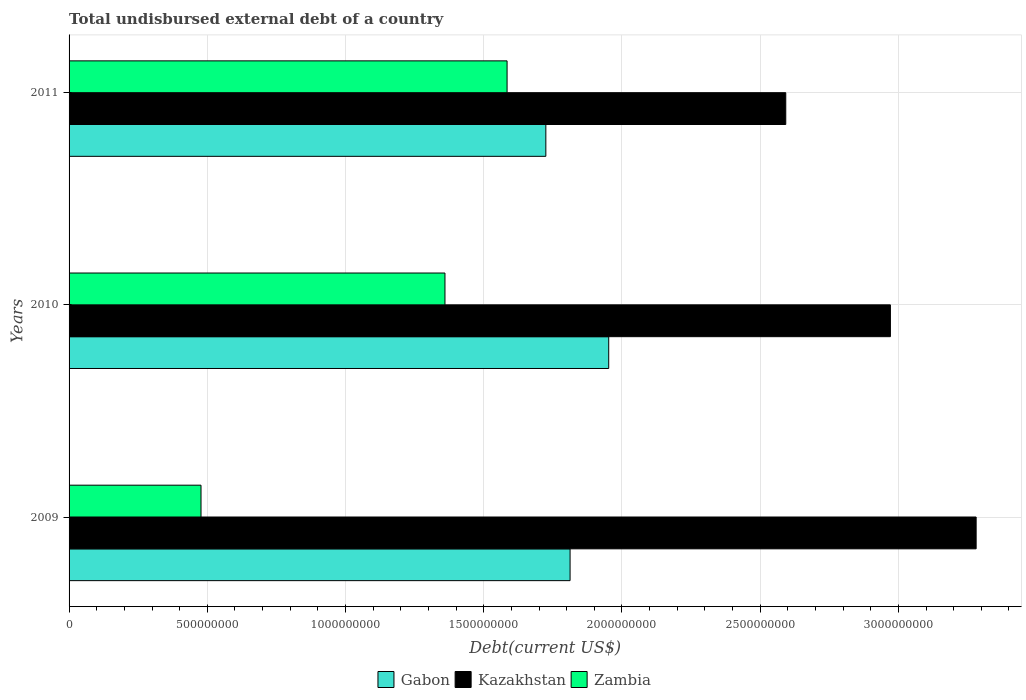How many groups of bars are there?
Give a very brief answer. 3. Are the number of bars per tick equal to the number of legend labels?
Your answer should be very brief. Yes. How many bars are there on the 1st tick from the top?
Provide a succinct answer. 3. What is the total undisbursed external debt in Kazakhstan in 2009?
Provide a succinct answer. 3.28e+09. Across all years, what is the maximum total undisbursed external debt in Zambia?
Provide a succinct answer. 1.58e+09. Across all years, what is the minimum total undisbursed external debt in Zambia?
Provide a succinct answer. 4.77e+08. In which year was the total undisbursed external debt in Kazakhstan maximum?
Give a very brief answer. 2009. In which year was the total undisbursed external debt in Gabon minimum?
Give a very brief answer. 2011. What is the total total undisbursed external debt in Zambia in the graph?
Offer a terse response. 3.42e+09. What is the difference between the total undisbursed external debt in Kazakhstan in 2009 and that in 2010?
Provide a succinct answer. 3.10e+08. What is the difference between the total undisbursed external debt in Gabon in 2010 and the total undisbursed external debt in Kazakhstan in 2011?
Your answer should be very brief. -6.40e+08. What is the average total undisbursed external debt in Kazakhstan per year?
Give a very brief answer. 2.95e+09. In the year 2011, what is the difference between the total undisbursed external debt in Gabon and total undisbursed external debt in Kazakhstan?
Offer a terse response. -8.68e+08. In how many years, is the total undisbursed external debt in Zambia greater than 2500000000 US$?
Your answer should be compact. 0. What is the ratio of the total undisbursed external debt in Zambia in 2010 to that in 2011?
Your answer should be very brief. 0.86. Is the total undisbursed external debt in Zambia in 2009 less than that in 2010?
Make the answer very short. Yes. Is the difference between the total undisbursed external debt in Gabon in 2009 and 2010 greater than the difference between the total undisbursed external debt in Kazakhstan in 2009 and 2010?
Give a very brief answer. No. What is the difference between the highest and the second highest total undisbursed external debt in Gabon?
Give a very brief answer. 1.40e+08. What is the difference between the highest and the lowest total undisbursed external debt in Kazakhstan?
Offer a terse response. 6.89e+08. In how many years, is the total undisbursed external debt in Kazakhstan greater than the average total undisbursed external debt in Kazakhstan taken over all years?
Give a very brief answer. 2. Is the sum of the total undisbursed external debt in Zambia in 2009 and 2011 greater than the maximum total undisbursed external debt in Gabon across all years?
Ensure brevity in your answer.  Yes. What does the 2nd bar from the top in 2011 represents?
Offer a very short reply. Kazakhstan. What does the 3rd bar from the bottom in 2009 represents?
Provide a succinct answer. Zambia. Is it the case that in every year, the sum of the total undisbursed external debt in Kazakhstan and total undisbursed external debt in Zambia is greater than the total undisbursed external debt in Gabon?
Give a very brief answer. Yes. How many bars are there?
Ensure brevity in your answer.  9. Are all the bars in the graph horizontal?
Ensure brevity in your answer.  Yes. How many years are there in the graph?
Offer a very short reply. 3. What is the difference between two consecutive major ticks on the X-axis?
Ensure brevity in your answer.  5.00e+08. Does the graph contain any zero values?
Offer a very short reply. No. What is the title of the graph?
Provide a succinct answer. Total undisbursed external debt of a country. Does "Djibouti" appear as one of the legend labels in the graph?
Ensure brevity in your answer.  No. What is the label or title of the X-axis?
Your answer should be compact. Debt(current US$). What is the label or title of the Y-axis?
Your answer should be very brief. Years. What is the Debt(current US$) of Gabon in 2009?
Provide a succinct answer. 1.81e+09. What is the Debt(current US$) in Kazakhstan in 2009?
Provide a short and direct response. 3.28e+09. What is the Debt(current US$) of Zambia in 2009?
Offer a terse response. 4.77e+08. What is the Debt(current US$) of Gabon in 2010?
Your answer should be compact. 1.95e+09. What is the Debt(current US$) of Kazakhstan in 2010?
Offer a terse response. 2.97e+09. What is the Debt(current US$) in Zambia in 2010?
Provide a short and direct response. 1.36e+09. What is the Debt(current US$) in Gabon in 2011?
Ensure brevity in your answer.  1.72e+09. What is the Debt(current US$) of Kazakhstan in 2011?
Offer a terse response. 2.59e+09. What is the Debt(current US$) in Zambia in 2011?
Ensure brevity in your answer.  1.58e+09. Across all years, what is the maximum Debt(current US$) in Gabon?
Make the answer very short. 1.95e+09. Across all years, what is the maximum Debt(current US$) of Kazakhstan?
Keep it short and to the point. 3.28e+09. Across all years, what is the maximum Debt(current US$) in Zambia?
Ensure brevity in your answer.  1.58e+09. Across all years, what is the minimum Debt(current US$) in Gabon?
Make the answer very short. 1.72e+09. Across all years, what is the minimum Debt(current US$) in Kazakhstan?
Ensure brevity in your answer.  2.59e+09. Across all years, what is the minimum Debt(current US$) of Zambia?
Provide a short and direct response. 4.77e+08. What is the total Debt(current US$) of Gabon in the graph?
Offer a very short reply. 5.49e+09. What is the total Debt(current US$) of Kazakhstan in the graph?
Offer a very short reply. 8.85e+09. What is the total Debt(current US$) in Zambia in the graph?
Provide a short and direct response. 3.42e+09. What is the difference between the Debt(current US$) of Gabon in 2009 and that in 2010?
Offer a very short reply. -1.40e+08. What is the difference between the Debt(current US$) of Kazakhstan in 2009 and that in 2010?
Your answer should be compact. 3.10e+08. What is the difference between the Debt(current US$) of Zambia in 2009 and that in 2010?
Offer a terse response. -8.83e+08. What is the difference between the Debt(current US$) of Gabon in 2009 and that in 2011?
Keep it short and to the point. 8.77e+07. What is the difference between the Debt(current US$) in Kazakhstan in 2009 and that in 2011?
Your answer should be very brief. 6.89e+08. What is the difference between the Debt(current US$) of Zambia in 2009 and that in 2011?
Your answer should be very brief. -1.11e+09. What is the difference between the Debt(current US$) in Gabon in 2010 and that in 2011?
Offer a terse response. 2.27e+08. What is the difference between the Debt(current US$) in Kazakhstan in 2010 and that in 2011?
Offer a very short reply. 3.79e+08. What is the difference between the Debt(current US$) in Zambia in 2010 and that in 2011?
Provide a succinct answer. -2.25e+08. What is the difference between the Debt(current US$) of Gabon in 2009 and the Debt(current US$) of Kazakhstan in 2010?
Provide a succinct answer. -1.16e+09. What is the difference between the Debt(current US$) in Gabon in 2009 and the Debt(current US$) in Zambia in 2010?
Provide a short and direct response. 4.53e+08. What is the difference between the Debt(current US$) of Kazakhstan in 2009 and the Debt(current US$) of Zambia in 2010?
Your response must be concise. 1.92e+09. What is the difference between the Debt(current US$) in Gabon in 2009 and the Debt(current US$) in Kazakhstan in 2011?
Offer a terse response. -7.80e+08. What is the difference between the Debt(current US$) of Gabon in 2009 and the Debt(current US$) of Zambia in 2011?
Your response must be concise. 2.28e+08. What is the difference between the Debt(current US$) of Kazakhstan in 2009 and the Debt(current US$) of Zambia in 2011?
Offer a terse response. 1.70e+09. What is the difference between the Debt(current US$) in Gabon in 2010 and the Debt(current US$) in Kazakhstan in 2011?
Provide a short and direct response. -6.40e+08. What is the difference between the Debt(current US$) in Gabon in 2010 and the Debt(current US$) in Zambia in 2011?
Provide a short and direct response. 3.68e+08. What is the difference between the Debt(current US$) in Kazakhstan in 2010 and the Debt(current US$) in Zambia in 2011?
Offer a terse response. 1.39e+09. What is the average Debt(current US$) in Gabon per year?
Offer a very short reply. 1.83e+09. What is the average Debt(current US$) of Kazakhstan per year?
Your response must be concise. 2.95e+09. What is the average Debt(current US$) of Zambia per year?
Give a very brief answer. 1.14e+09. In the year 2009, what is the difference between the Debt(current US$) of Gabon and Debt(current US$) of Kazakhstan?
Give a very brief answer. -1.47e+09. In the year 2009, what is the difference between the Debt(current US$) in Gabon and Debt(current US$) in Zambia?
Your answer should be very brief. 1.34e+09. In the year 2009, what is the difference between the Debt(current US$) in Kazakhstan and Debt(current US$) in Zambia?
Offer a terse response. 2.80e+09. In the year 2010, what is the difference between the Debt(current US$) of Gabon and Debt(current US$) of Kazakhstan?
Offer a very short reply. -1.02e+09. In the year 2010, what is the difference between the Debt(current US$) of Gabon and Debt(current US$) of Zambia?
Keep it short and to the point. 5.92e+08. In the year 2010, what is the difference between the Debt(current US$) of Kazakhstan and Debt(current US$) of Zambia?
Provide a succinct answer. 1.61e+09. In the year 2011, what is the difference between the Debt(current US$) of Gabon and Debt(current US$) of Kazakhstan?
Give a very brief answer. -8.68e+08. In the year 2011, what is the difference between the Debt(current US$) of Gabon and Debt(current US$) of Zambia?
Your answer should be very brief. 1.40e+08. In the year 2011, what is the difference between the Debt(current US$) of Kazakhstan and Debt(current US$) of Zambia?
Give a very brief answer. 1.01e+09. What is the ratio of the Debt(current US$) in Gabon in 2009 to that in 2010?
Give a very brief answer. 0.93. What is the ratio of the Debt(current US$) of Kazakhstan in 2009 to that in 2010?
Your answer should be very brief. 1.1. What is the ratio of the Debt(current US$) of Zambia in 2009 to that in 2010?
Your response must be concise. 0.35. What is the ratio of the Debt(current US$) in Gabon in 2009 to that in 2011?
Make the answer very short. 1.05. What is the ratio of the Debt(current US$) of Kazakhstan in 2009 to that in 2011?
Give a very brief answer. 1.27. What is the ratio of the Debt(current US$) of Zambia in 2009 to that in 2011?
Offer a very short reply. 0.3. What is the ratio of the Debt(current US$) in Gabon in 2010 to that in 2011?
Give a very brief answer. 1.13. What is the ratio of the Debt(current US$) in Kazakhstan in 2010 to that in 2011?
Provide a short and direct response. 1.15. What is the ratio of the Debt(current US$) of Zambia in 2010 to that in 2011?
Give a very brief answer. 0.86. What is the difference between the highest and the second highest Debt(current US$) in Gabon?
Give a very brief answer. 1.40e+08. What is the difference between the highest and the second highest Debt(current US$) in Kazakhstan?
Keep it short and to the point. 3.10e+08. What is the difference between the highest and the second highest Debt(current US$) of Zambia?
Offer a very short reply. 2.25e+08. What is the difference between the highest and the lowest Debt(current US$) of Gabon?
Your answer should be very brief. 2.27e+08. What is the difference between the highest and the lowest Debt(current US$) of Kazakhstan?
Keep it short and to the point. 6.89e+08. What is the difference between the highest and the lowest Debt(current US$) of Zambia?
Your answer should be very brief. 1.11e+09. 